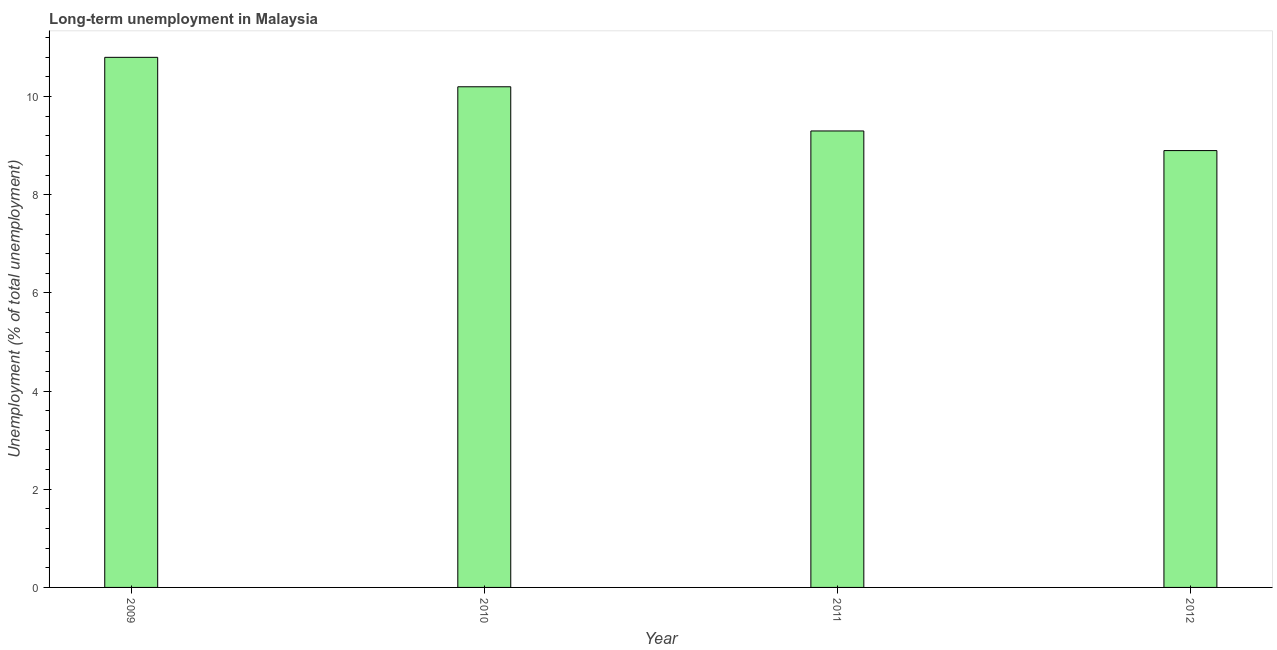Does the graph contain grids?
Keep it short and to the point. No. What is the title of the graph?
Your answer should be very brief. Long-term unemployment in Malaysia. What is the label or title of the Y-axis?
Keep it short and to the point. Unemployment (% of total unemployment). What is the long-term unemployment in 2009?
Your answer should be very brief. 10.8. Across all years, what is the maximum long-term unemployment?
Provide a short and direct response. 10.8. Across all years, what is the minimum long-term unemployment?
Your answer should be compact. 8.9. In which year was the long-term unemployment minimum?
Provide a succinct answer. 2012. What is the sum of the long-term unemployment?
Give a very brief answer. 39.2. What is the difference between the long-term unemployment in 2009 and 2012?
Offer a very short reply. 1.9. What is the median long-term unemployment?
Provide a succinct answer. 9.75. In how many years, is the long-term unemployment greater than 8.4 %?
Offer a terse response. 4. What is the ratio of the long-term unemployment in 2011 to that in 2012?
Provide a short and direct response. 1.04. Is the long-term unemployment in 2010 less than that in 2012?
Your answer should be very brief. No. Is the difference between the long-term unemployment in 2011 and 2012 greater than the difference between any two years?
Your answer should be compact. No. What is the difference between the highest and the second highest long-term unemployment?
Provide a short and direct response. 0.6. Is the sum of the long-term unemployment in 2009 and 2012 greater than the maximum long-term unemployment across all years?
Make the answer very short. Yes. What is the difference between the highest and the lowest long-term unemployment?
Make the answer very short. 1.9. In how many years, is the long-term unemployment greater than the average long-term unemployment taken over all years?
Offer a terse response. 2. How many bars are there?
Your response must be concise. 4. Are the values on the major ticks of Y-axis written in scientific E-notation?
Your response must be concise. No. What is the Unemployment (% of total unemployment) of 2009?
Provide a short and direct response. 10.8. What is the Unemployment (% of total unemployment) in 2010?
Your response must be concise. 10.2. What is the Unemployment (% of total unemployment) of 2011?
Your answer should be very brief. 9.3. What is the Unemployment (% of total unemployment) of 2012?
Your response must be concise. 8.9. What is the difference between the Unemployment (% of total unemployment) in 2009 and 2010?
Your answer should be compact. 0.6. What is the difference between the Unemployment (% of total unemployment) in 2009 and 2011?
Your answer should be very brief. 1.5. What is the difference between the Unemployment (% of total unemployment) in 2009 and 2012?
Your answer should be compact. 1.9. What is the difference between the Unemployment (% of total unemployment) in 2010 and 2011?
Offer a terse response. 0.9. What is the difference between the Unemployment (% of total unemployment) in 2010 and 2012?
Keep it short and to the point. 1.3. What is the difference between the Unemployment (% of total unemployment) in 2011 and 2012?
Make the answer very short. 0.4. What is the ratio of the Unemployment (% of total unemployment) in 2009 to that in 2010?
Provide a short and direct response. 1.06. What is the ratio of the Unemployment (% of total unemployment) in 2009 to that in 2011?
Your answer should be compact. 1.16. What is the ratio of the Unemployment (% of total unemployment) in 2009 to that in 2012?
Your answer should be very brief. 1.21. What is the ratio of the Unemployment (% of total unemployment) in 2010 to that in 2011?
Ensure brevity in your answer.  1.1. What is the ratio of the Unemployment (% of total unemployment) in 2010 to that in 2012?
Offer a terse response. 1.15. What is the ratio of the Unemployment (% of total unemployment) in 2011 to that in 2012?
Your answer should be compact. 1.04. 